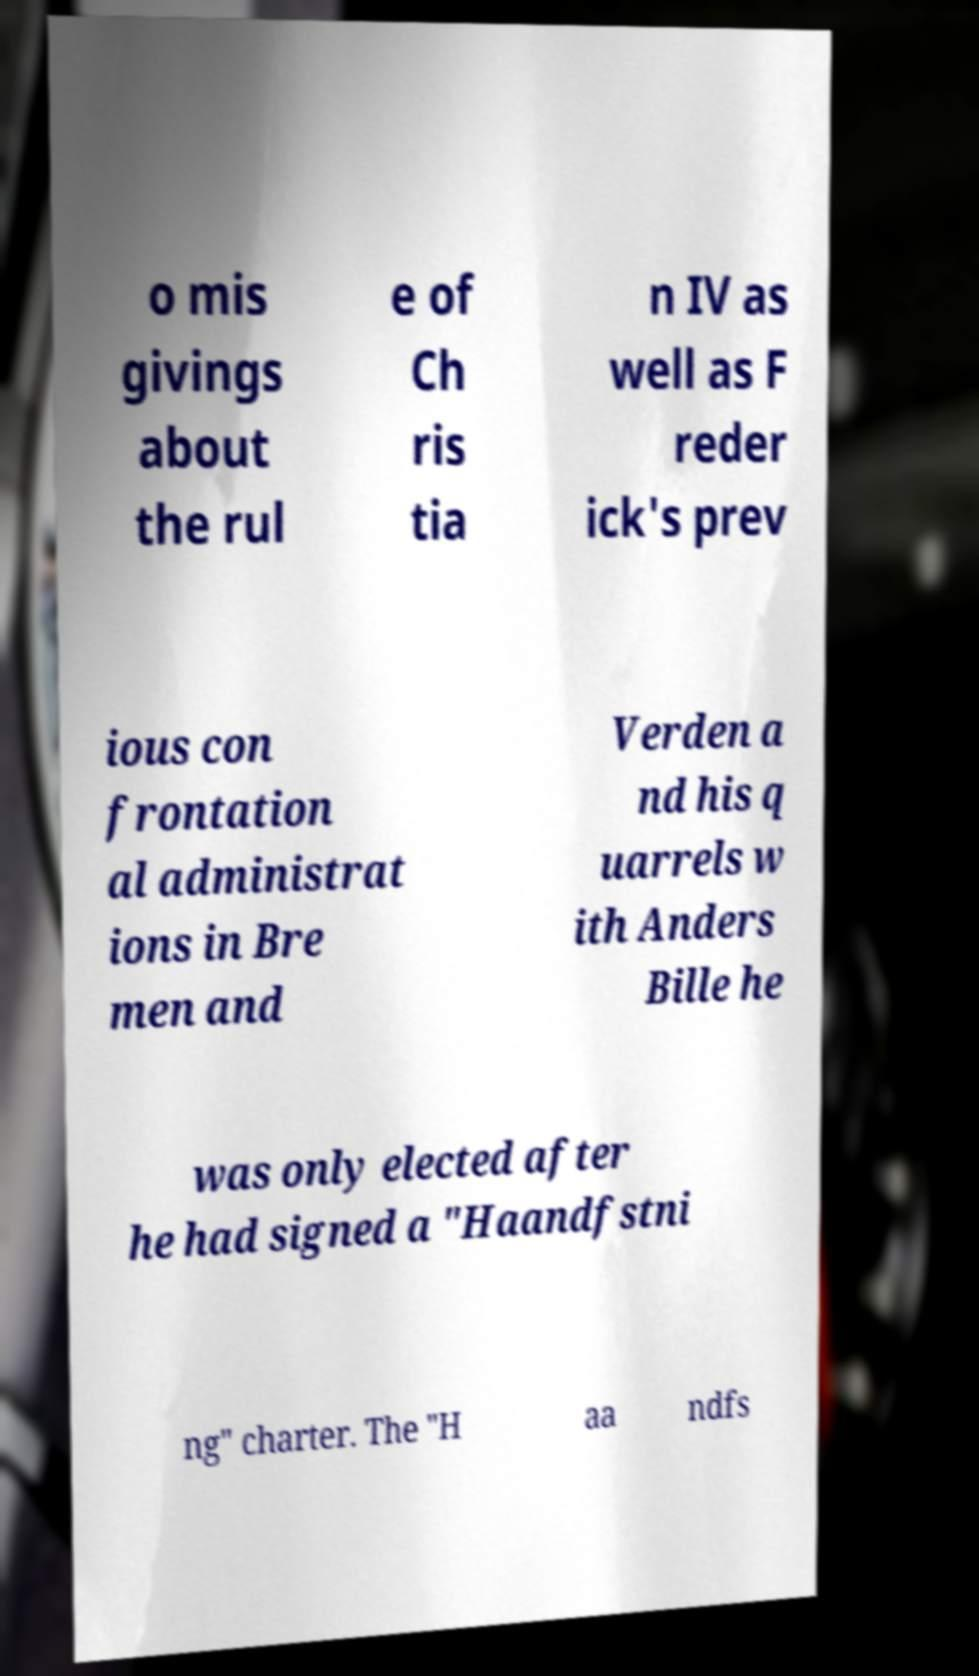Could you assist in decoding the text presented in this image and type it out clearly? o mis givings about the rul e of Ch ris tia n IV as well as F reder ick's prev ious con frontation al administrat ions in Bre men and Verden a nd his q uarrels w ith Anders Bille he was only elected after he had signed a "Haandfstni ng" charter. The "H aa ndfs 